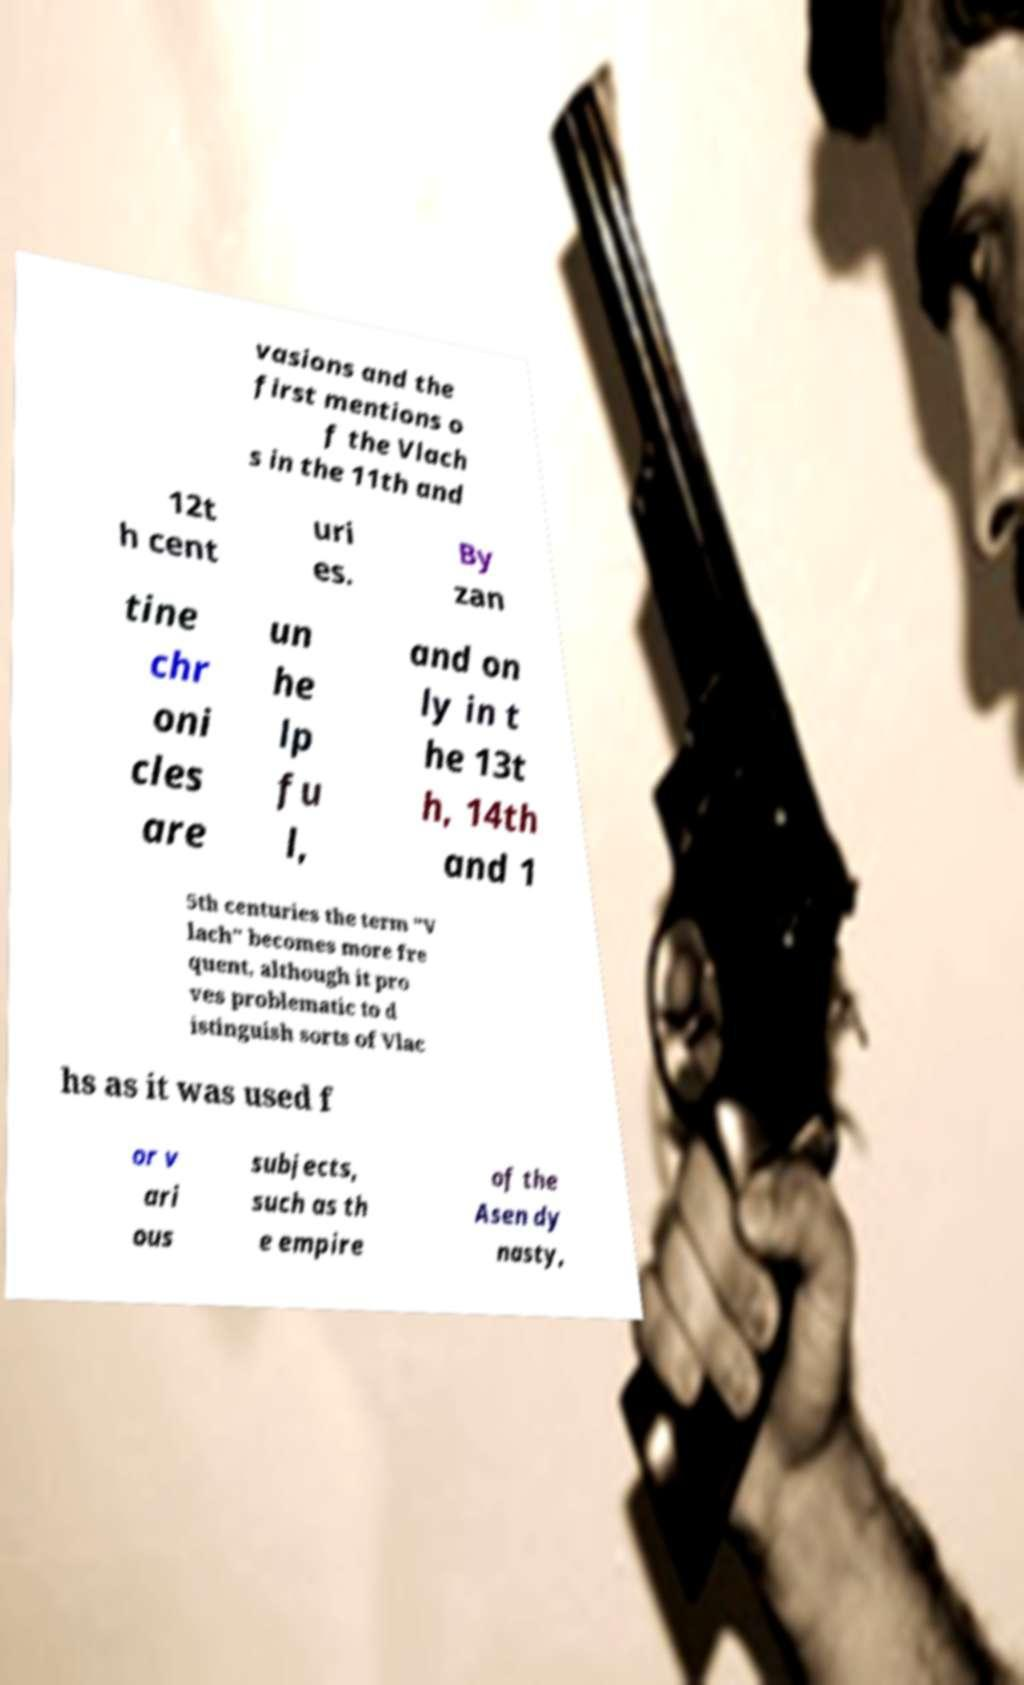Please identify and transcribe the text found in this image. vasions and the first mentions o f the Vlach s in the 11th and 12t h cent uri es. By zan tine chr oni cles are un he lp fu l, and on ly in t he 13t h, 14th and 1 5th centuries the term "V lach" becomes more fre quent, although it pro ves problematic to d istinguish sorts of Vlac hs as it was used f or v ari ous subjects, such as th e empire of the Asen dy nasty, 